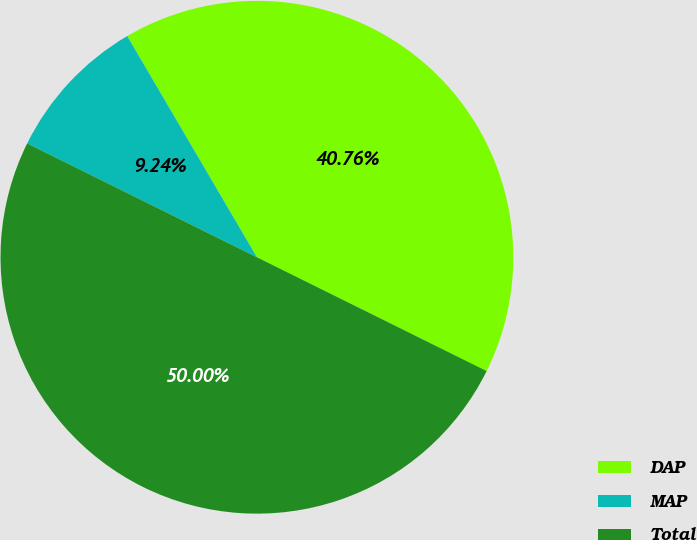Convert chart. <chart><loc_0><loc_0><loc_500><loc_500><pie_chart><fcel>DAP<fcel>MAP<fcel>Total<nl><fcel>40.76%<fcel>9.24%<fcel>50.0%<nl></chart> 